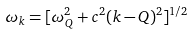Convert formula to latex. <formula><loc_0><loc_0><loc_500><loc_500>\omega _ { k } = [ \omega ^ { 2 } _ { Q } + c ^ { 2 } ( { k - Q } ) ^ { 2 } ] ^ { 1 / 2 }</formula> 